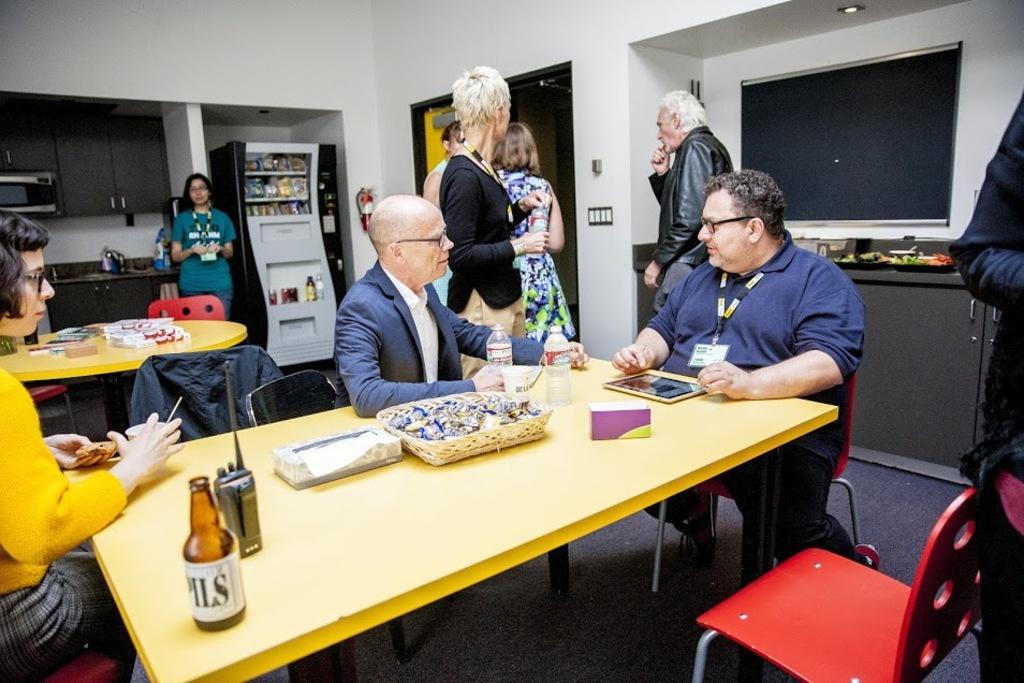How would you summarize this image in a sentence or two? In this picture there is a room in which there is a table and beside the table there are few people sitting around it, on the table there is glass bottle,mic,tab,bottle on it. At the background there is a fridge and beside it there is a woman. To the right corner there is a television under which there is a cupboard. 